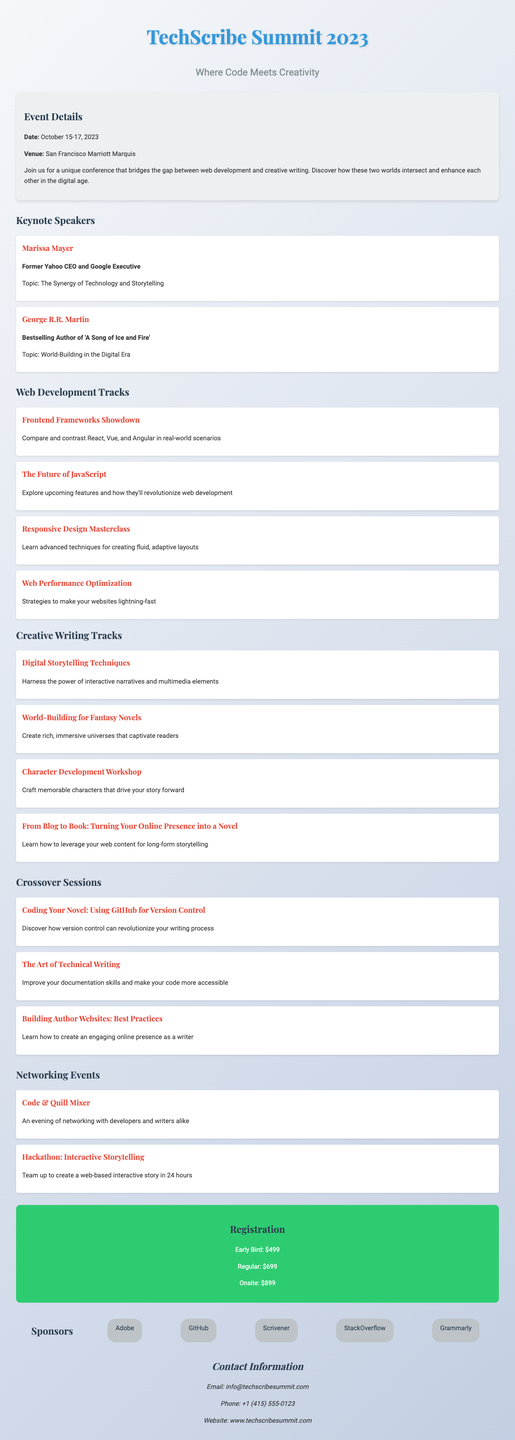What are the dates of the conference? The dates of the conference are listed in the event details section.
Answer: October 15-17, 2023 Who is one of the keynote speakers? The keynote speakers are highlighted in the document.
Answer: Marissa Mayer What is the registration fee for early bird participants? The early bird registration fee is specified in the registration section.
Answer: $499 What is one of the web development tracks offered? The web development tracks are detailed in a specific section of the document.
Answer: Frontend Frameworks Showdown How many crossover sessions are there? The number of crossover sessions can be counted in the crossover sessions section.
Answer: 3 What is the name of the networking event focused on interactive storytelling? The networking events section lists an event that aligns with interactive storytelling.
Answer: Hackathon: Interactive Storytelling What is the venue for the conference? The venue of the conference is provided in the event details section.
Answer: San Francisco Marriott Marquis What type of techniques will be discussed in the "Responsive Design Masterclass"? The description for each track outlines the focus of the respective sessions.
Answer: Advanced techniques for creating fluid, adaptive layouts 